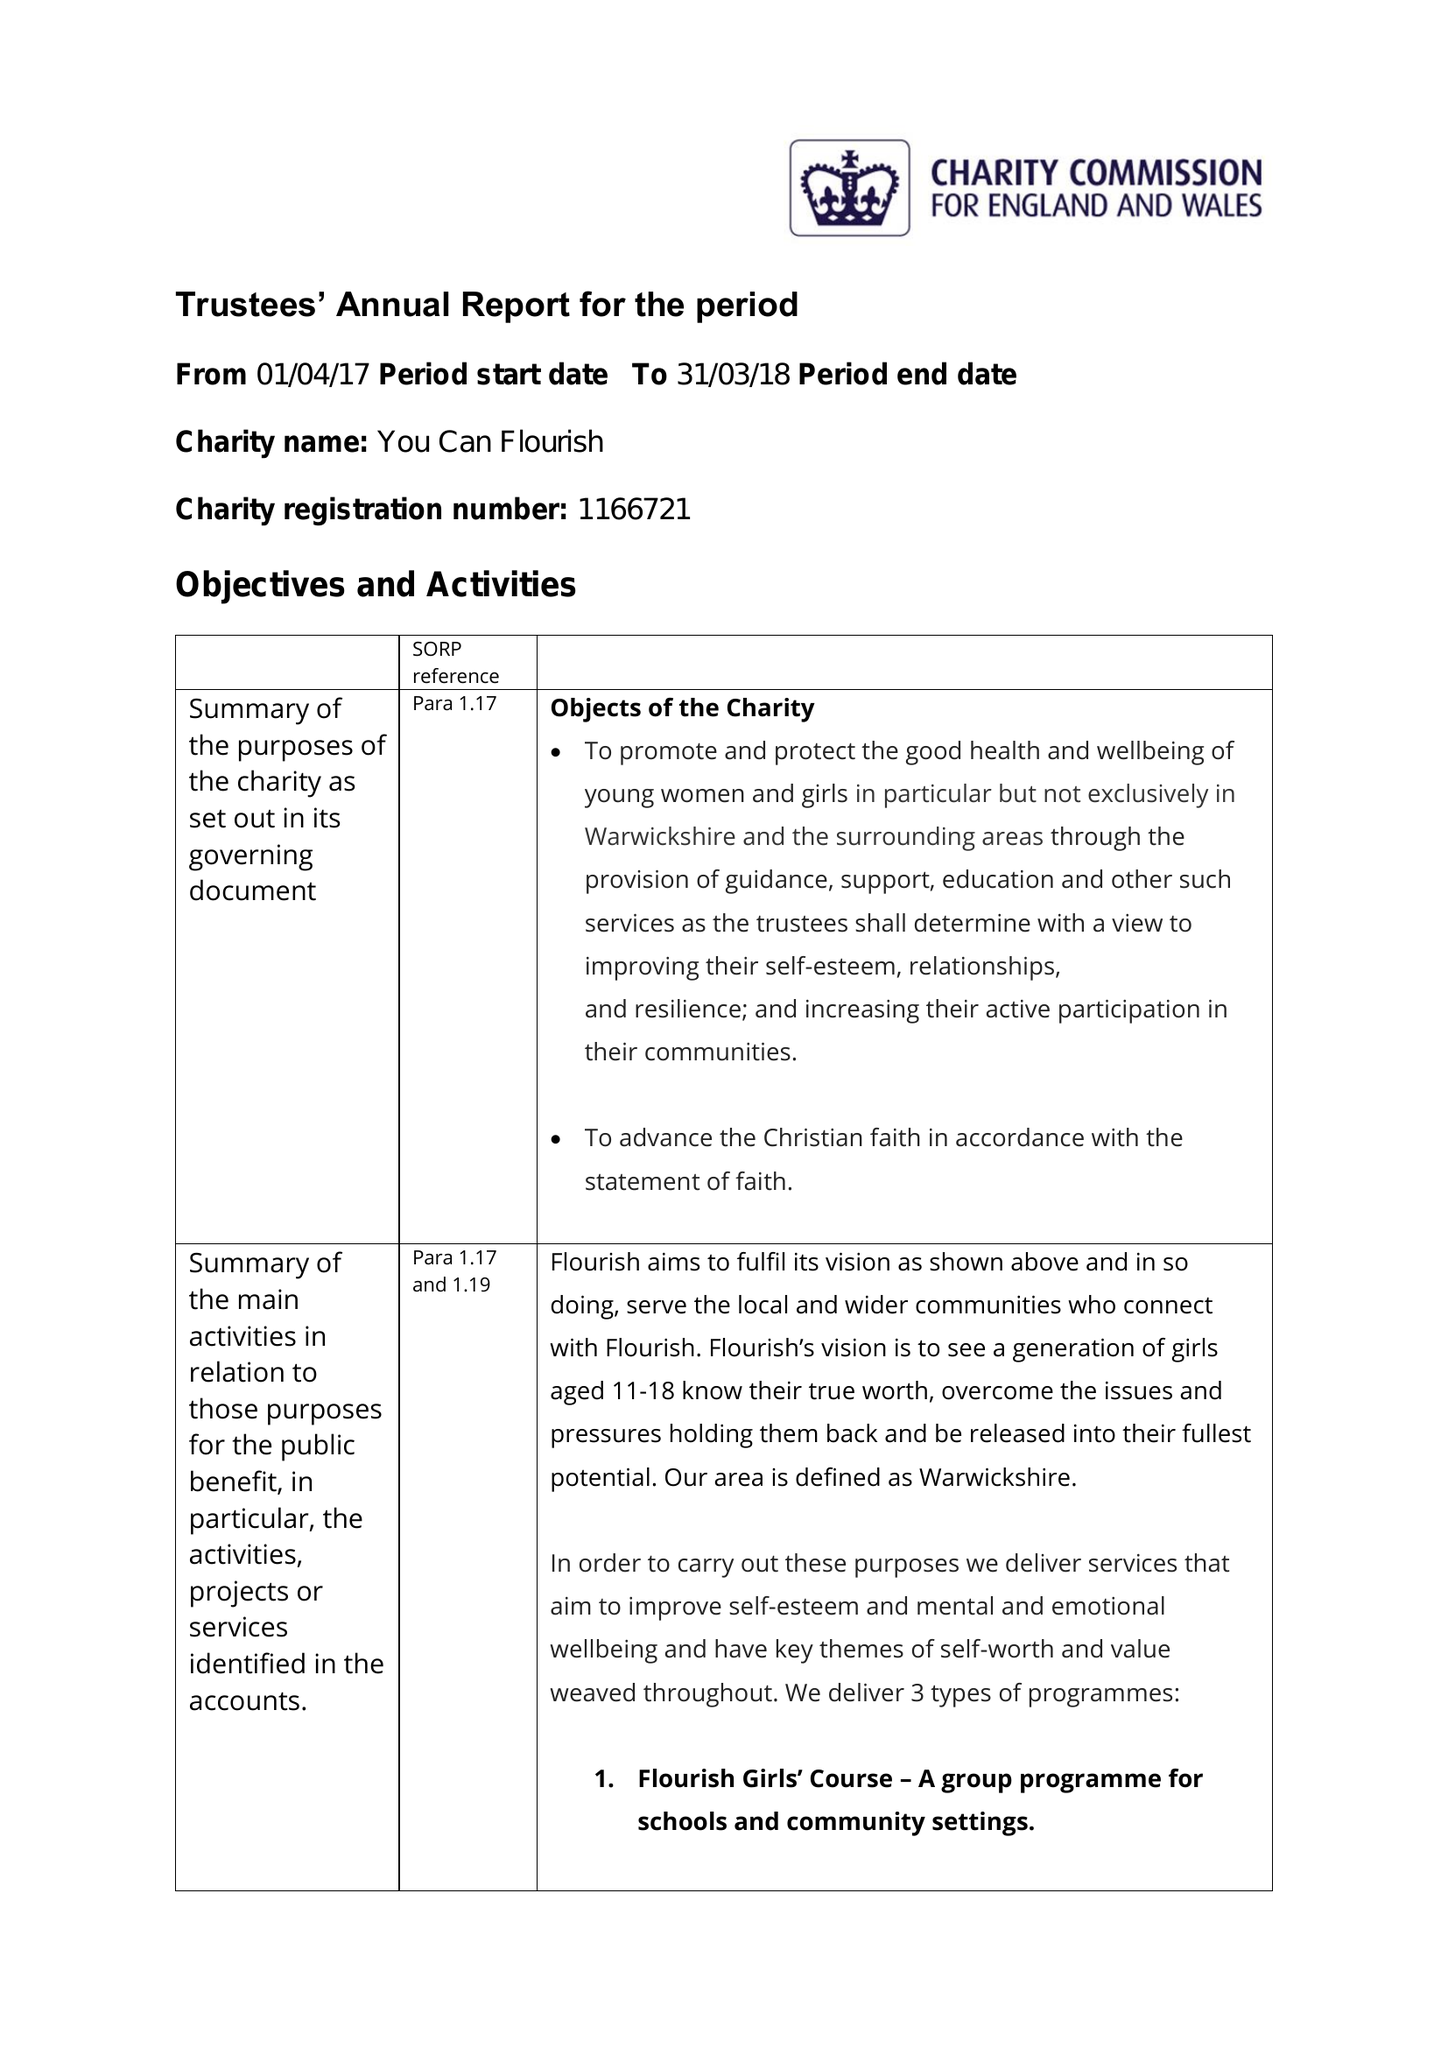What is the value for the charity_name?
Answer the question using a single word or phrase. You Can Flourish 